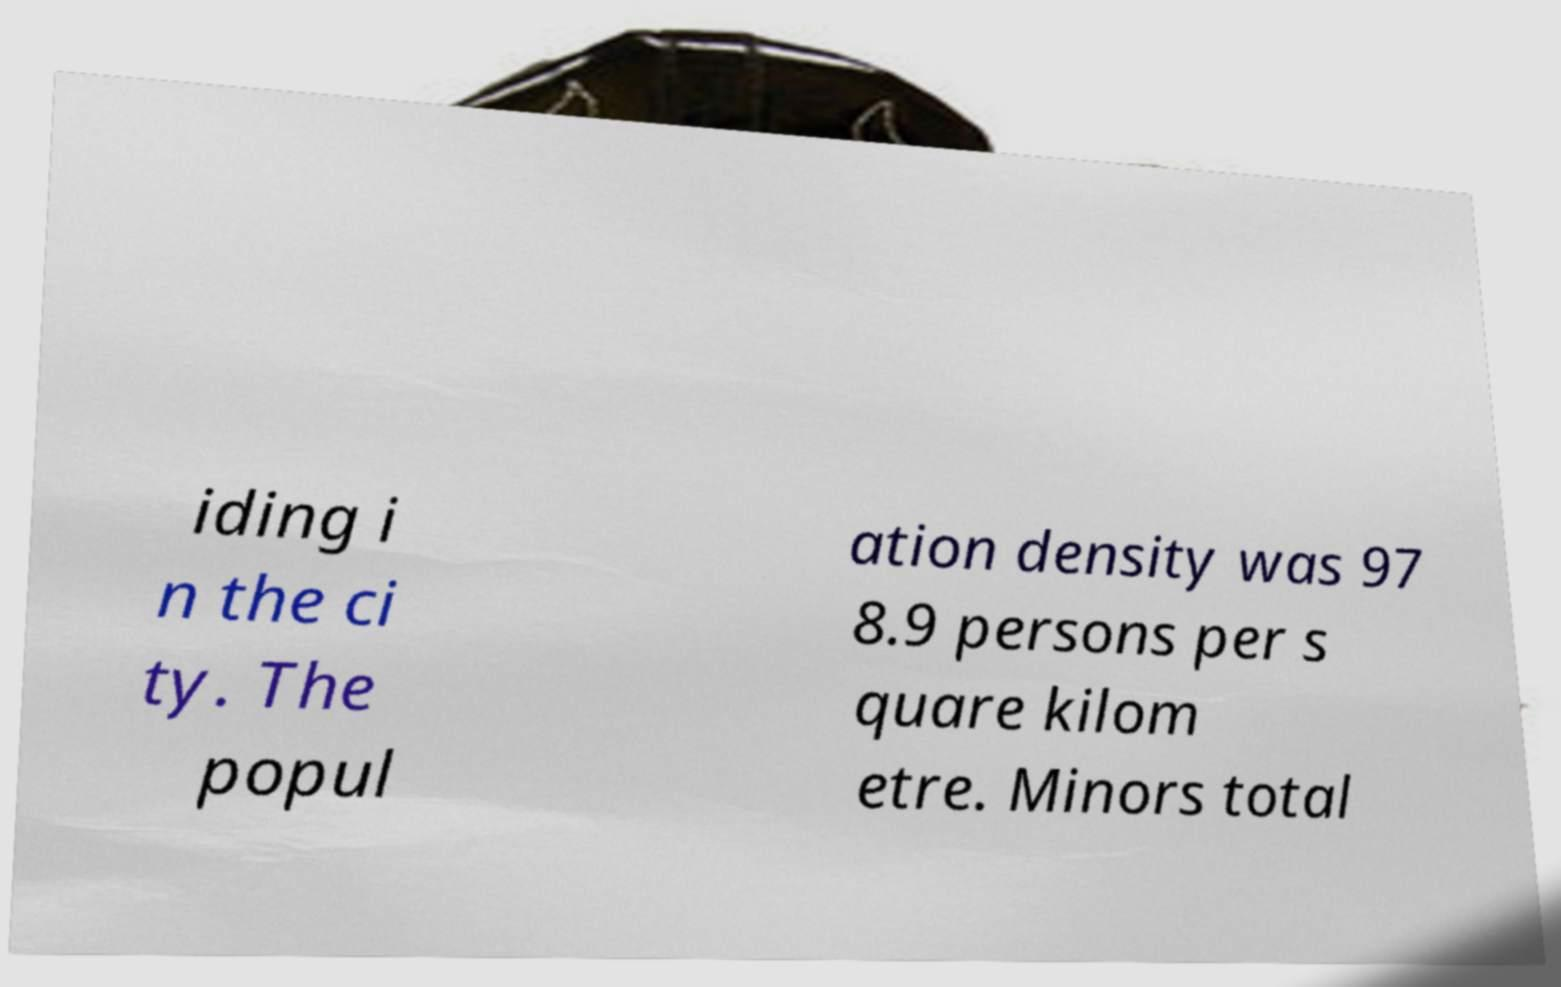I need the written content from this picture converted into text. Can you do that? iding i n the ci ty. The popul ation density was 97 8.9 persons per s quare kilom etre. Minors total 